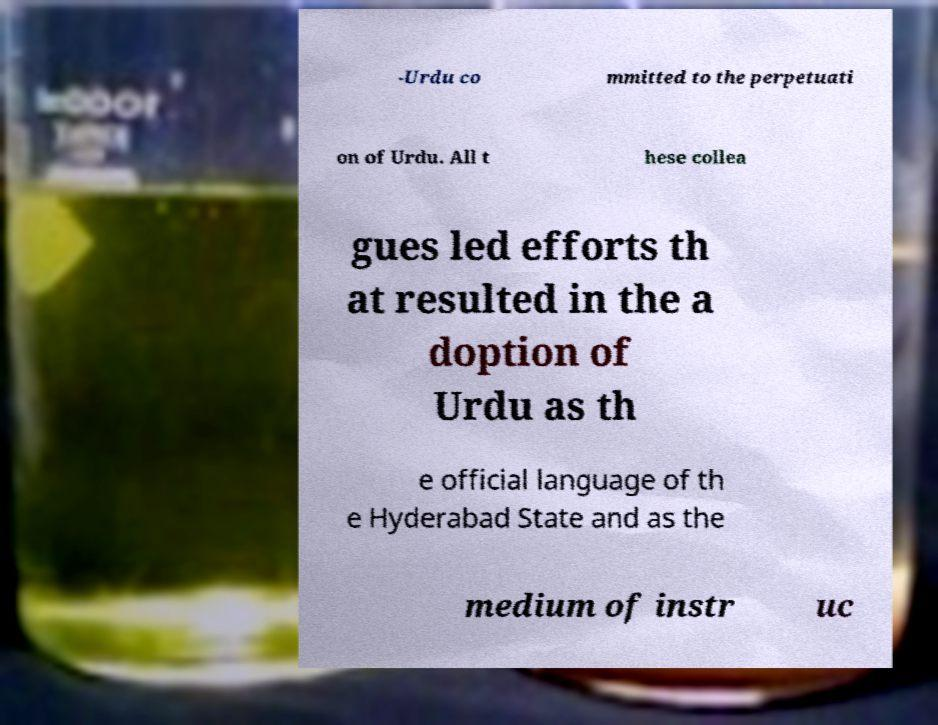Please read and relay the text visible in this image. What does it say? -Urdu co mmitted to the perpetuati on of Urdu. All t hese collea gues led efforts th at resulted in the a doption of Urdu as th e official language of th e Hyderabad State and as the medium of instr uc 